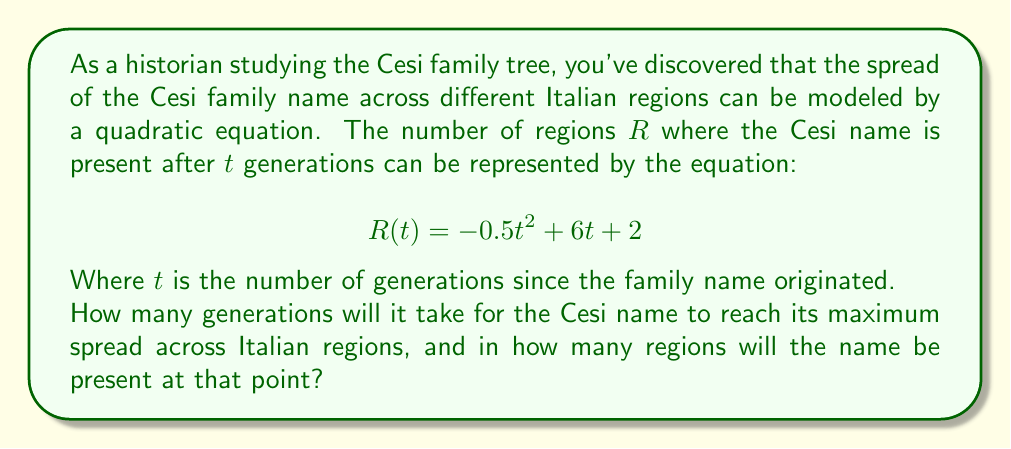Teach me how to tackle this problem. To solve this problem, we need to follow these steps:

1) The quadratic equation given is in the form $R(t) = -0.5t^2 + 6t + 2$, which is a parabola that opens downward due to the negative coefficient of $t^2$.

2) The maximum point of a parabola occurs at the vertex. For a quadratic equation in the form $f(x) = ax^2 + bx + c$, the x-coordinate of the vertex is given by $x = -\frac{b}{2a}$.

3) In our equation, $a = -0.5$ and $b = 6$. Let's calculate the t-coordinate of the vertex:

   $t = -\frac{6}{2(-0.5)} = -\frac{6}{-1} = 6$

4) This means the Cesi name will reach its maximum spread after 6 generations.

5) To find the number of regions at this maximum point, we need to substitute $t = 6$ into our original equation:

   $R(6) = -0.5(6)^2 + 6(6) + 2$
   $= -0.5(36) + 36 + 2$
   $= -18 + 36 + 2$
   $= 20$

Therefore, after 6 generations, the Cesi name will be present in 20 regions.
Answer: The Cesi name will reach its maximum spread after 6 generations, at which point it will be present in 20 regions. 